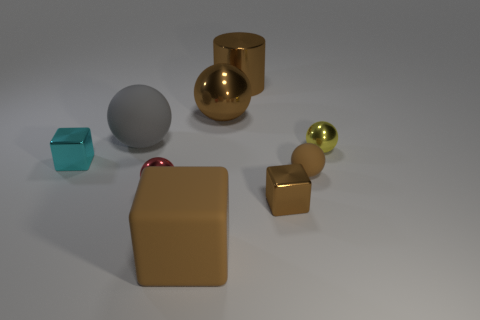Subtract all big brown spheres. How many spheres are left? 4 Add 1 small brown spheres. How many objects exist? 10 Subtract all yellow balls. How many balls are left? 4 Subtract all cylinders. How many objects are left? 8 Subtract all cyan cylinders. How many brown blocks are left? 2 Subtract 1 gray balls. How many objects are left? 8 Subtract 4 spheres. How many spheres are left? 1 Subtract all yellow blocks. Subtract all green spheres. How many blocks are left? 3 Subtract all tiny yellow spheres. Subtract all large green matte cylinders. How many objects are left? 8 Add 4 tiny objects. How many tiny objects are left? 9 